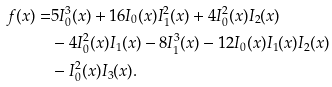Convert formula to latex. <formula><loc_0><loc_0><loc_500><loc_500>f ( x ) = & 5 I _ { 0 } ^ { 3 } ( x ) + 1 6 I _ { 0 } ( x ) I _ { 1 } ^ { 2 } ( x ) + 4 I _ { 0 } ^ { 2 } ( x ) I _ { 2 } ( x ) \\ & - 4 I _ { 0 } ^ { 2 } ( x ) I _ { 1 } ( x ) - 8 I _ { 1 } ^ { 3 } ( x ) - 1 2 I _ { 0 } ( x ) I _ { 1 } ( x ) I _ { 2 } ( x ) \\ & - I _ { 0 } ^ { 2 } ( x ) I _ { 3 } ( x ) .</formula> 